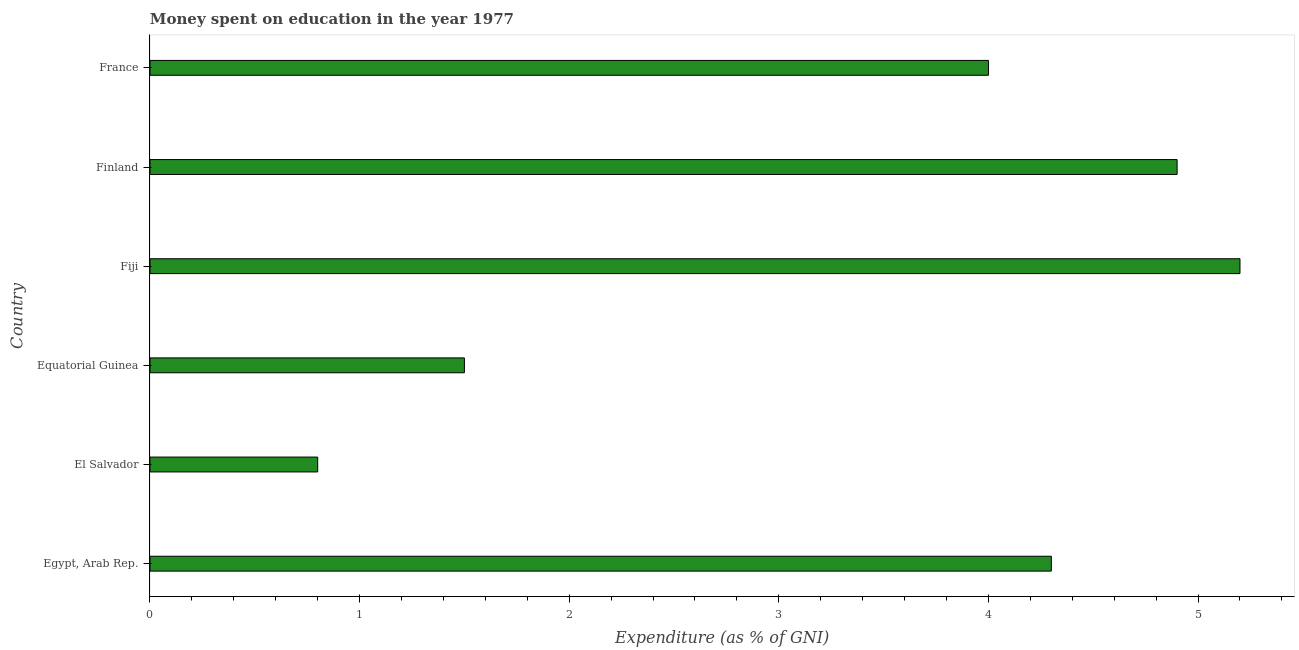What is the title of the graph?
Ensure brevity in your answer.  Money spent on education in the year 1977. What is the label or title of the X-axis?
Keep it short and to the point. Expenditure (as % of GNI). In which country was the expenditure on education maximum?
Your response must be concise. Fiji. In which country was the expenditure on education minimum?
Your answer should be very brief. El Salvador. What is the sum of the expenditure on education?
Make the answer very short. 20.7. What is the difference between the expenditure on education in El Salvador and Fiji?
Provide a short and direct response. -4.4. What is the average expenditure on education per country?
Your answer should be compact. 3.45. What is the median expenditure on education?
Offer a terse response. 4.15. In how many countries, is the expenditure on education greater than 1 %?
Keep it short and to the point. 5. What is the ratio of the expenditure on education in Egypt, Arab Rep. to that in Finland?
Provide a succinct answer. 0.88. Is the expenditure on education in Equatorial Guinea less than that in Fiji?
Your response must be concise. Yes. What is the difference between the highest and the second highest expenditure on education?
Give a very brief answer. 0.3. How many bars are there?
Make the answer very short. 6. What is the difference between two consecutive major ticks on the X-axis?
Make the answer very short. 1. Are the values on the major ticks of X-axis written in scientific E-notation?
Offer a very short reply. No. What is the Expenditure (as % of GNI) of Equatorial Guinea?
Provide a succinct answer. 1.5. What is the Expenditure (as % of GNI) of Finland?
Provide a short and direct response. 4.9. What is the difference between the Expenditure (as % of GNI) in Egypt, Arab Rep. and El Salvador?
Provide a short and direct response. 3.5. What is the difference between the Expenditure (as % of GNI) in Egypt, Arab Rep. and Finland?
Offer a very short reply. -0.6. What is the difference between the Expenditure (as % of GNI) in Egypt, Arab Rep. and France?
Your response must be concise. 0.3. What is the difference between the Expenditure (as % of GNI) in El Salvador and Fiji?
Ensure brevity in your answer.  -4.4. What is the difference between the Expenditure (as % of GNI) in Equatorial Guinea and Finland?
Provide a succinct answer. -3.4. What is the difference between the Expenditure (as % of GNI) in Fiji and Finland?
Keep it short and to the point. 0.3. What is the ratio of the Expenditure (as % of GNI) in Egypt, Arab Rep. to that in El Salvador?
Give a very brief answer. 5.38. What is the ratio of the Expenditure (as % of GNI) in Egypt, Arab Rep. to that in Equatorial Guinea?
Your answer should be very brief. 2.87. What is the ratio of the Expenditure (as % of GNI) in Egypt, Arab Rep. to that in Fiji?
Your response must be concise. 0.83. What is the ratio of the Expenditure (as % of GNI) in Egypt, Arab Rep. to that in Finland?
Offer a very short reply. 0.88. What is the ratio of the Expenditure (as % of GNI) in Egypt, Arab Rep. to that in France?
Give a very brief answer. 1.07. What is the ratio of the Expenditure (as % of GNI) in El Salvador to that in Equatorial Guinea?
Provide a succinct answer. 0.53. What is the ratio of the Expenditure (as % of GNI) in El Salvador to that in Fiji?
Give a very brief answer. 0.15. What is the ratio of the Expenditure (as % of GNI) in El Salvador to that in Finland?
Your answer should be compact. 0.16. What is the ratio of the Expenditure (as % of GNI) in Equatorial Guinea to that in Fiji?
Give a very brief answer. 0.29. What is the ratio of the Expenditure (as % of GNI) in Equatorial Guinea to that in Finland?
Your response must be concise. 0.31. What is the ratio of the Expenditure (as % of GNI) in Fiji to that in Finland?
Ensure brevity in your answer.  1.06. What is the ratio of the Expenditure (as % of GNI) in Finland to that in France?
Your answer should be very brief. 1.23. 